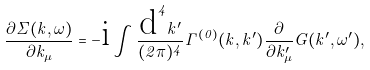Convert formula to latex. <formula><loc_0><loc_0><loc_500><loc_500>\frac { \partial \Sigma ( k , \omega ) } { \partial k _ { \mu } } = - \mbox i \int \frac { \mbox d ^ { 4 } k ^ { \prime } } { ( 2 \pi ) ^ { 4 } } \Gamma ^ { ( 0 ) } ( k , k ^ { \prime } ) \frac { \partial } { \partial k ^ { \prime } _ { \mu } } G ( k ^ { \prime } , \omega ^ { \prime } ) ,</formula> 